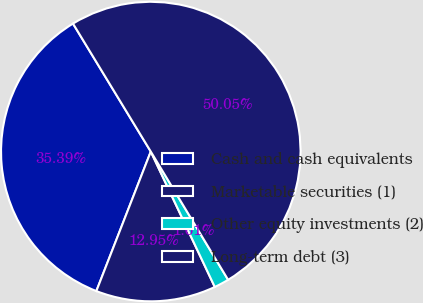Convert chart to OTSL. <chart><loc_0><loc_0><loc_500><loc_500><pie_chart><fcel>Cash and cash equivalents<fcel>Marketable securities (1)<fcel>Other equity investments (2)<fcel>Long-term debt (3)<nl><fcel>35.39%<fcel>12.95%<fcel>1.61%<fcel>50.06%<nl></chart> 